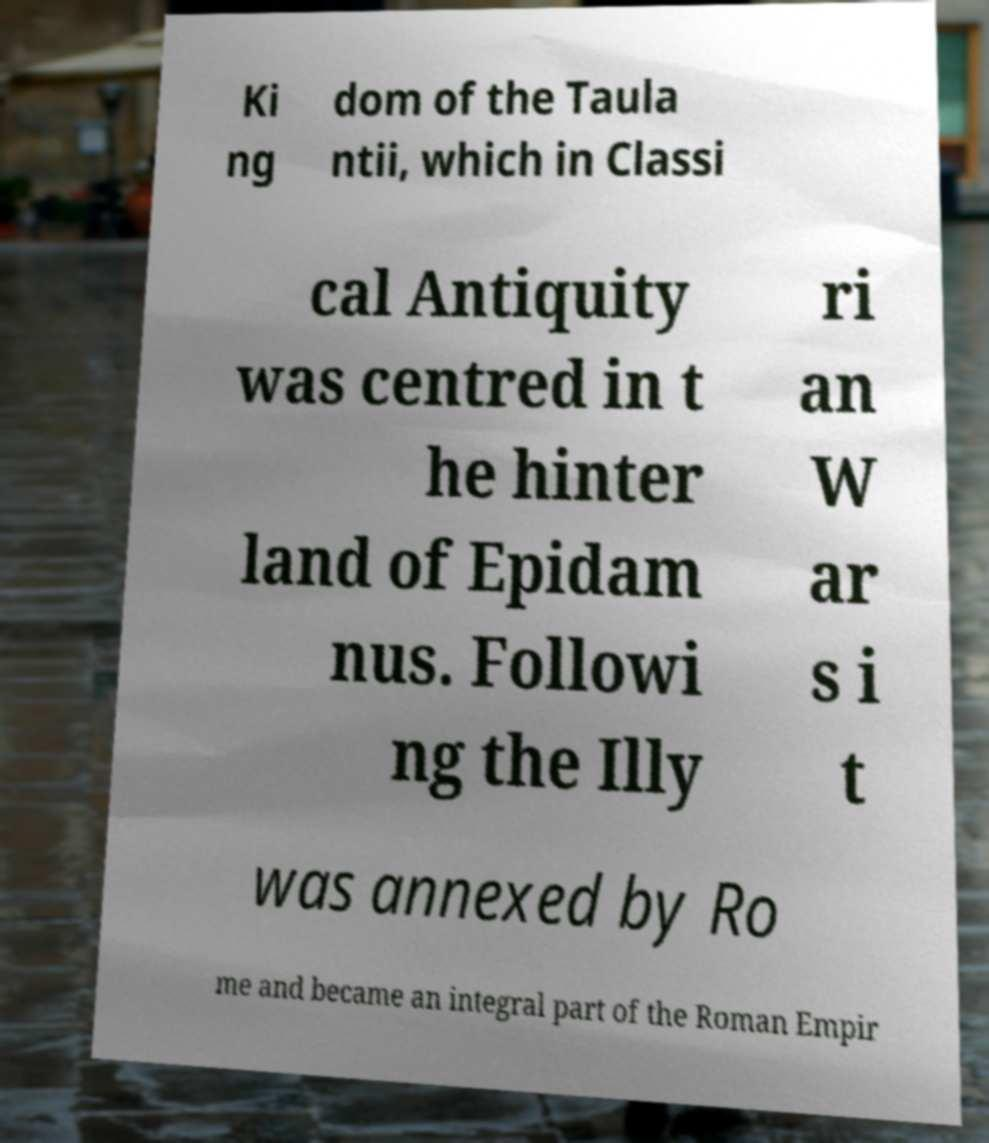Can you read and provide the text displayed in the image?This photo seems to have some interesting text. Can you extract and type it out for me? Ki ng dom of the Taula ntii, which in Classi cal Antiquity was centred in t he hinter land of Epidam nus. Followi ng the Illy ri an W ar s i t was annexed by Ro me and became an integral part of the Roman Empir 